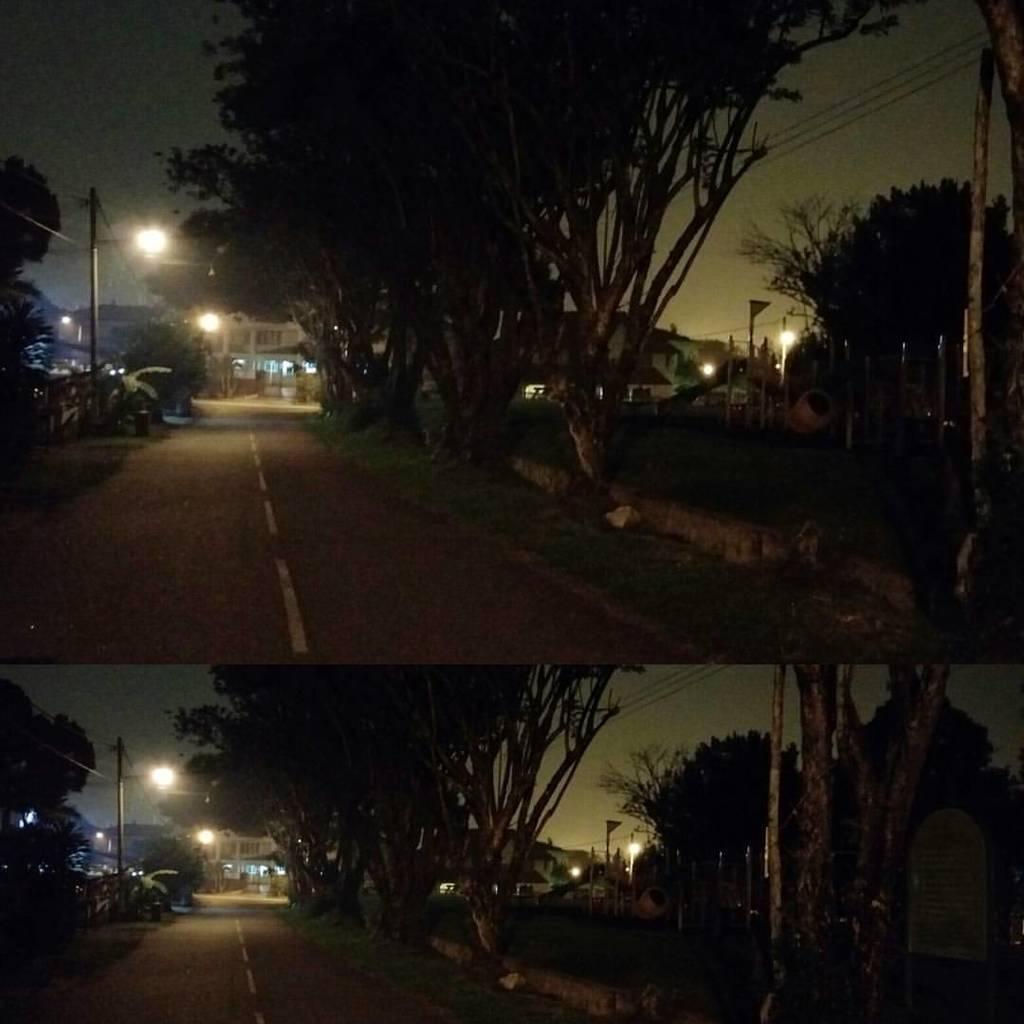In one or two sentences, can you explain what this image depicts? This is an edited image. This image is the collage of two images. In the above image, we see the road and the grass. On the right side, we see the trees, poles and street lights. On the left side, we see the trees, electric pole and wires. There are trees, street lights and the buildings in the background. At the top, we see the sky. At the bottom, we see the road, grass, trees, poles, street lights and buildings. On the right side, we see a board in white color with some text written on it. 